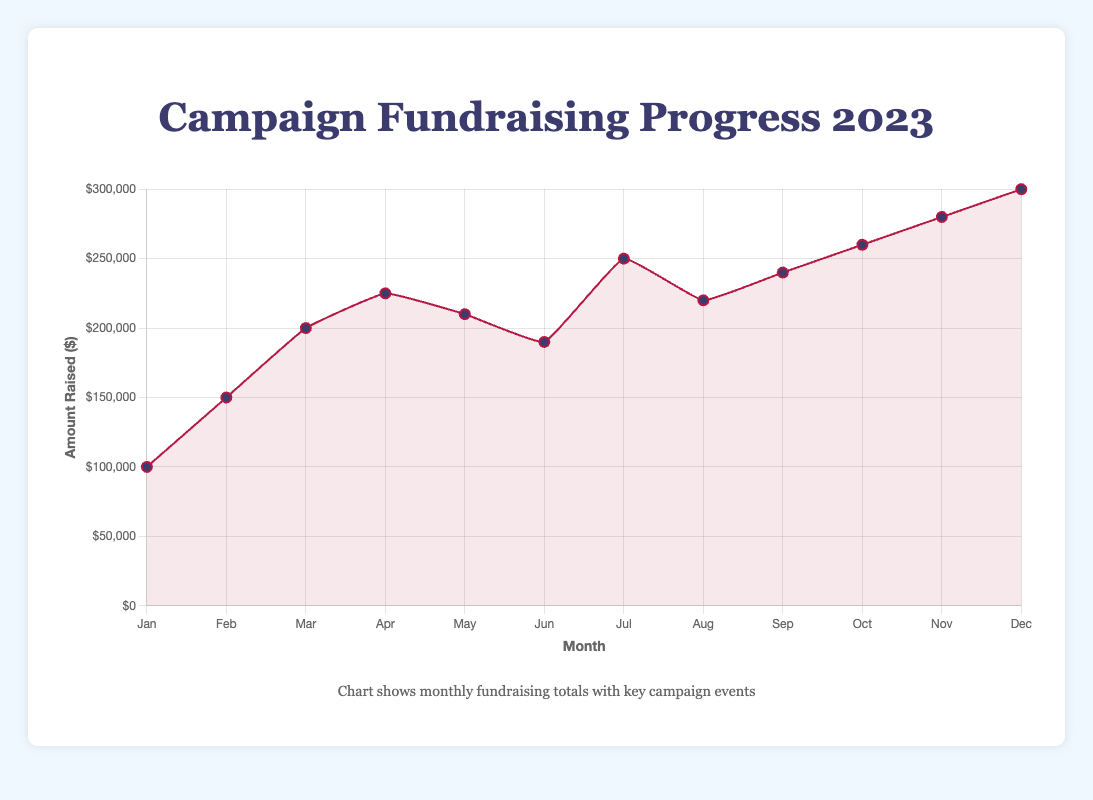What's the total amount of funds raised by the end of June? Sum the monthly fundraising totals from January to June: 100,000 + 150,000 + 200,000 + 225,000 + 210,000 + 190,000 = 1,075,000
Answer: 1,075,000 By how much did the fundraising total increase from January to February? Subtract the fundraising amount in January from the amount in February: 150,000 - 100,000 = 50,000
Answer: 50,000 Which month saw the highest amount of funds raised? According to the chart, December has the highest fundraising total amounting to 300,000
Answer: December How does the fundraising total in May (after the Chicago Outreach) compare to April (after the Town Hall meeting)? The amount raised in April is 225,000, and in May, it is 210,000. Therefore, May saw a decrease compared to April: 210,000 < 225,000
Answer: Decreased What's the average monthly fundraising amount in the second half of the year (July to December)? Calculate the sum for the months July to December and divide by the number of months: (250,000 + 220,000 + 240,000 + 260,000 + 280,000 + 300,000) / 6 = 1,550,000 / 6 = approximately 258,333.33
Answer: approximately 258,333.33 Which event led to the biggest immediate increase in funds raised the following month? Compare the increases associated with each event by looking at monthly differences. The biggest increase follows “Major Endorsement from Senator Smith” in July: 250,000 (July) - 190,000 (June) = 60,000
Answer: Major Endorsement from Senator Smith How much did the amount raised in October exceed the amount in September? Subtract the September amount from the October amount: 260,000 - 240,000 = 20,000
Answer: 20,000 What's the total fundraising amount for the first quarter of the year (January to March)? Sum monthly totals for January, February, and March: 100,000 + 150,000 + 200,000 = 450,000
Answer: 450,000 Do any two successive months have the same fundraising totals? Review the amounts for each month to check for any equal successive totals. No successive months have the same total
Answer: No How did the fundraising total change from July to August? Subtract July's total from August's amount: 220,000 - 250,000 = -30,000, indicating a decrease
Answer: Decreased 